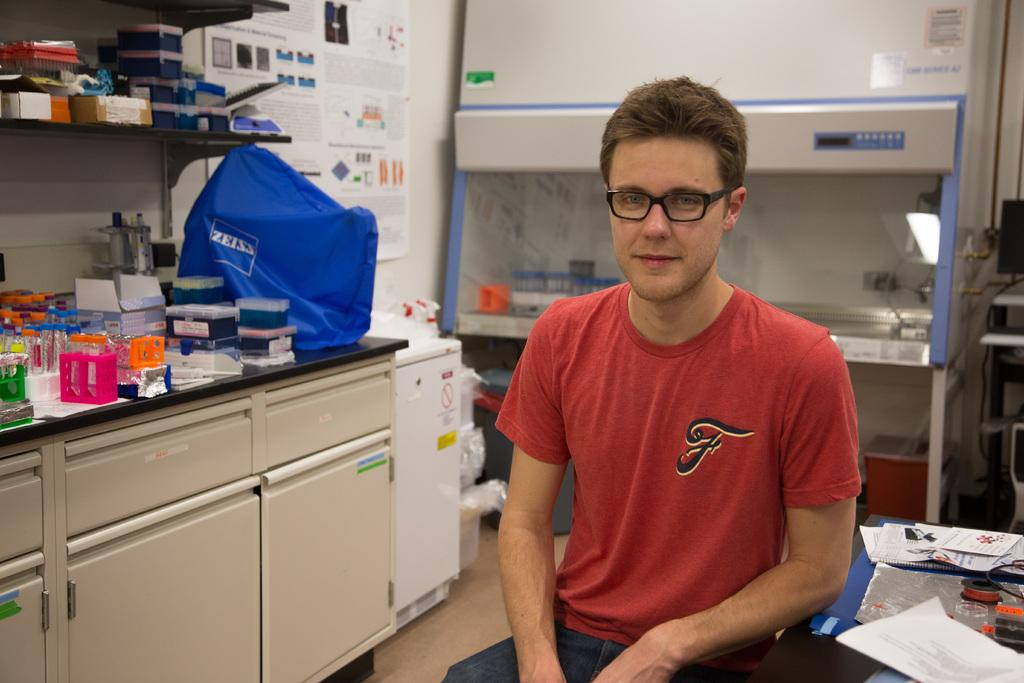<image>
Render a clear and concise summary of the photo. A man with a large F on his red shirt sits in a science lab. 